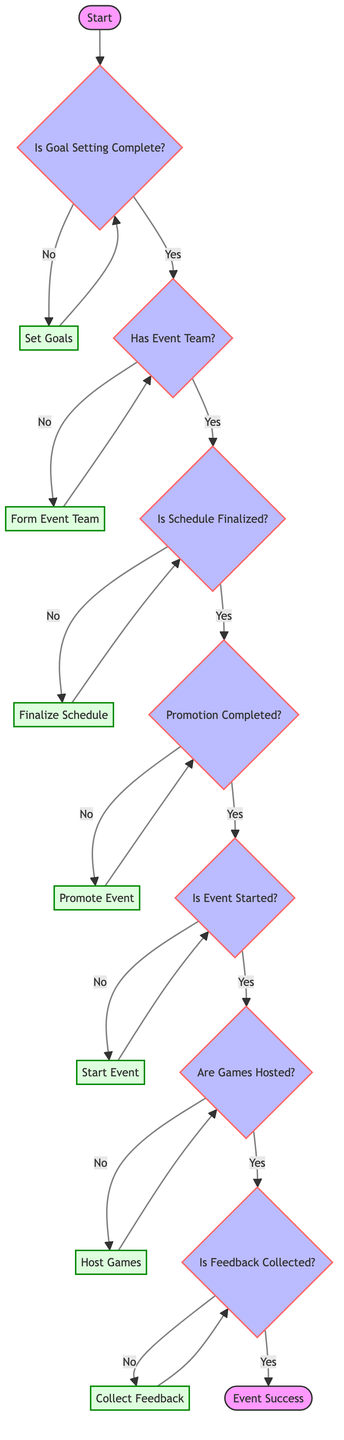Is goal setting complete? The first decision node asks whether goal setting is complete. Following the flow from "Start," if one answers 'No,' the next step is to "Set Goals." If the answer is 'Yes,' we progress to the next decision node regarding whether there is an event team.
Answer: No How many process steps are there before collecting feedback? To answer this, we trace the path from "Start" through to "Collect Feedback." Counting the process nodes between these steps: Set Goals, Form Event Team, Finalize Schedule, Promote Event, Start Event, and Host Games gives us a total of six steps.
Answer: 6 What happens if the event schedule is not finalized? Referring to the diagram, if "Is Schedule Finalized" is answered 'No,' the flow directs to the process node "Finalize Schedule," indicating that finalizing the schedule is necessary before proceeding.
Answer: Finalize Schedule What is required before starting the event? Before "Start Event," the flow requires that the promotion is completed. From the previous decision node, if "Promotion Completed" is answered 'No,' it leads to "Promote Event," indicating promotion must occur first.
Answer: Promote Event What is the final output if feedback is collected? According to the decision path after "Collect Feedback," if feedback is successfully gathered, the flow ends at "Event Success," indicating a positive result.
Answer: Event Success What comes after hosting games? From the "Are Games Hosted?" decision node, if the answer is 'Yes,' the next step is "Is Feedback Collected?", which means collecting feedback is the subsequent action after the games are hosted.
Answer: Is Feedback Collected How many decision nodes are there in total? Counting all decision nodes in the diagram, we see that they are: "Is Goal Setting Complete," "Has Event Team," "Is Schedule Finalized," "Promotion Completed," "Is Event Started," "Are Games Hosted," and "Is Feedback Collected." This gives us a total of six decision nodes.
Answer: 6 What action is taken if there are no games hosted? When "Are Games Hosted?" results in 'No,' the flow directs to "Host Games," indicating that the next action is to host the games before proceeding.
Answer: Host Games If there is no event team, what is the next step? If at the decision node "Has Event Team," the answer is 'No,' the flow directs to "Form Event Team." This step becomes crucial before continuing the planning process.
Answer: Form Event Team 